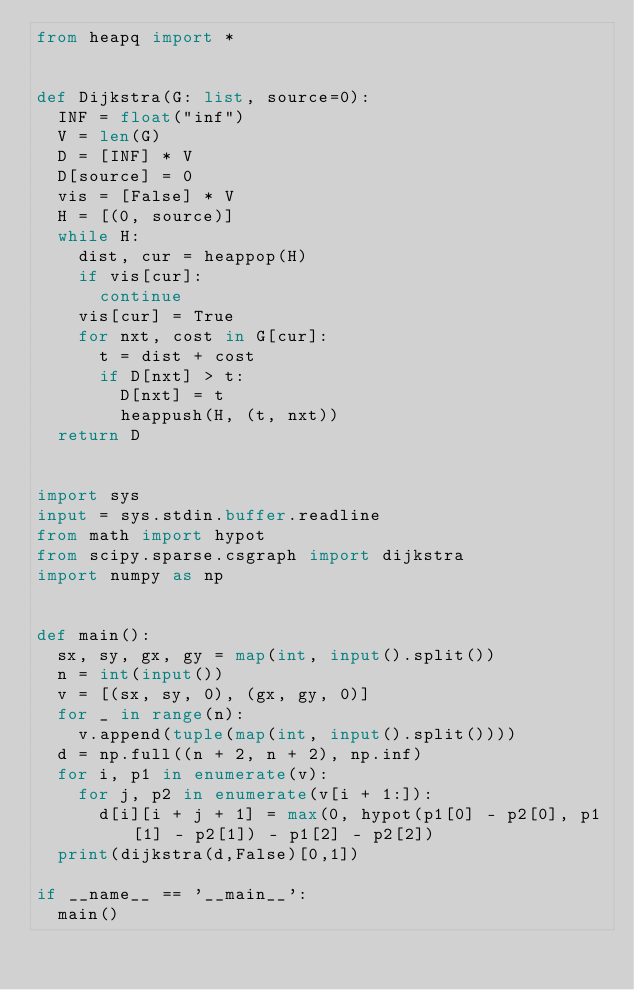<code> <loc_0><loc_0><loc_500><loc_500><_Python_>from heapq import *


def Dijkstra(G: list, source=0):
	INF = float("inf")
	V = len(G)
	D = [INF] * V
	D[source] = 0
	vis = [False] * V
	H = [(0, source)]
	while H:
		dist, cur = heappop(H)
		if vis[cur]:
			continue
		vis[cur] = True
		for nxt, cost in G[cur]:
			t = dist + cost
			if D[nxt] > t:
				D[nxt] = t
				heappush(H, (t, nxt))
	return D


import sys
input = sys.stdin.buffer.readline
from math import hypot
from scipy.sparse.csgraph import dijkstra
import numpy as np


def main():
	sx, sy, gx, gy = map(int, input().split())
	n = int(input())
	v = [(sx, sy, 0), (gx, gy, 0)]
	for _ in range(n):
		v.append(tuple(map(int, input().split())))
	d = np.full((n + 2, n + 2), np.inf)
	for i, p1 in enumerate(v):
		for j, p2 in enumerate(v[i + 1:]):
			d[i][i + j + 1] = max(0, hypot(p1[0] - p2[0], p1[1] - p2[1]) - p1[2] - p2[2])
	print(dijkstra(d,False)[0,1])

if __name__ == '__main__':
	main()
</code> 